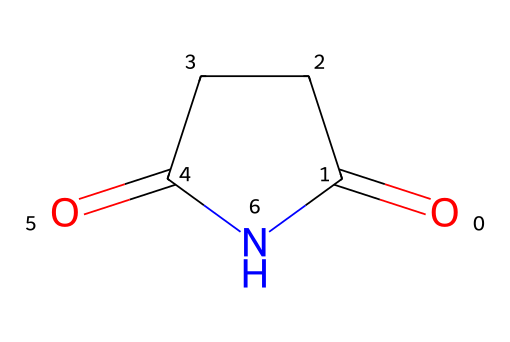What is the molecular formula of succinimide? The SMILES representation reveals that the molecule has a carbonyl and an imide functional group. By counting the individual carbon (C), hydrogen (H), nitrogen (N), and oxygen (O) atoms from the structure, we determine the molecular formula.
Answer: C4H5N1O2 How many carbon atoms are in succinimide? Observing the SMILES representation, we identify four carbon (C) atoms in the structure.
Answer: 4 What functional groups are present in succinimide? The chemical structure shows both a carbonyl group (C=O) and an imide group, which is characteristic of this compound.
Answer: imide and carbonyl Why is succinimide effective as a flame retardant? The presence of the carbonyl and imide groups in succinimide provides thermal stability and inhibits combustion by promoting char formation when exposed to flames.
Answer: thermal stability How many rings are present in the structure of succinimide? The visual structure indicates that succinimide contains a cyclic component due to the imide structure, which forms one ring.
Answer: 1 What is the unique feature of imides, as observed in succinimide? The defining characteristic of imides, such as in succinimide, is the presence of the cyclic structure formed by the combination of carbonyl and nitrogen atoms.
Answer: cyclic structure with carbonyl and nitrogen 